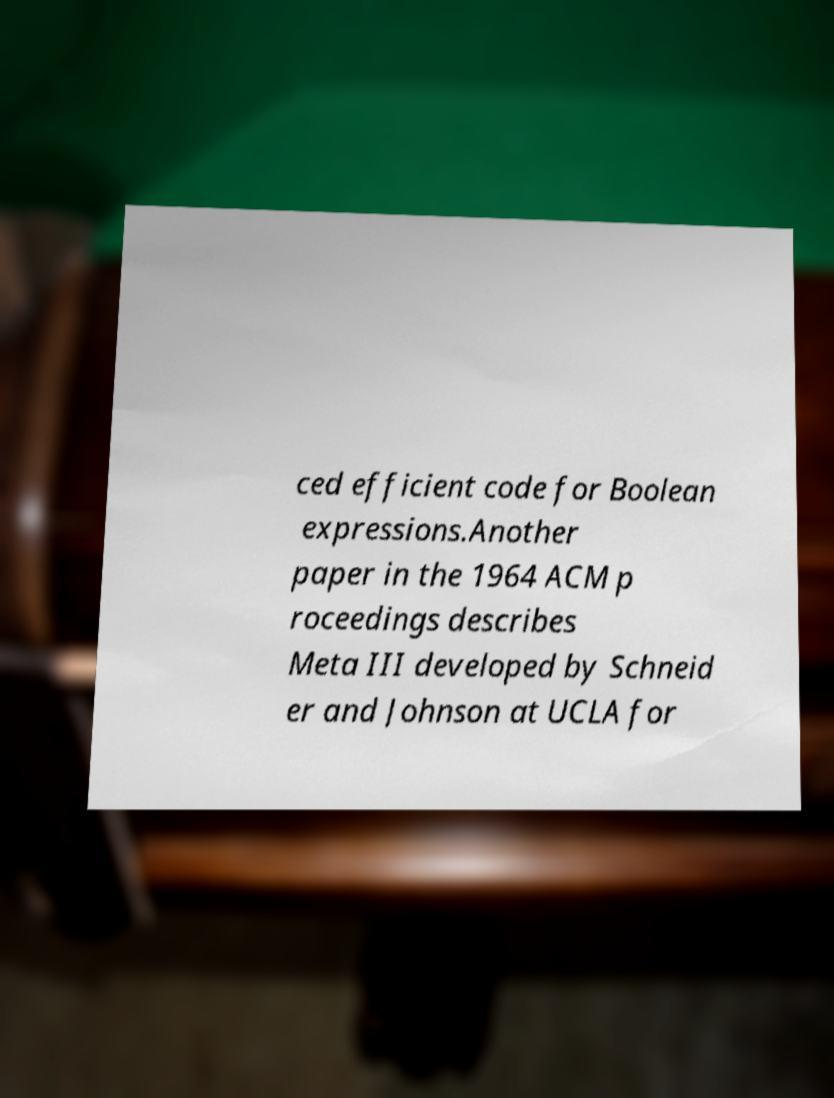I need the written content from this picture converted into text. Can you do that? ced efficient code for Boolean expressions.Another paper in the 1964 ACM p roceedings describes Meta III developed by Schneid er and Johnson at UCLA for 